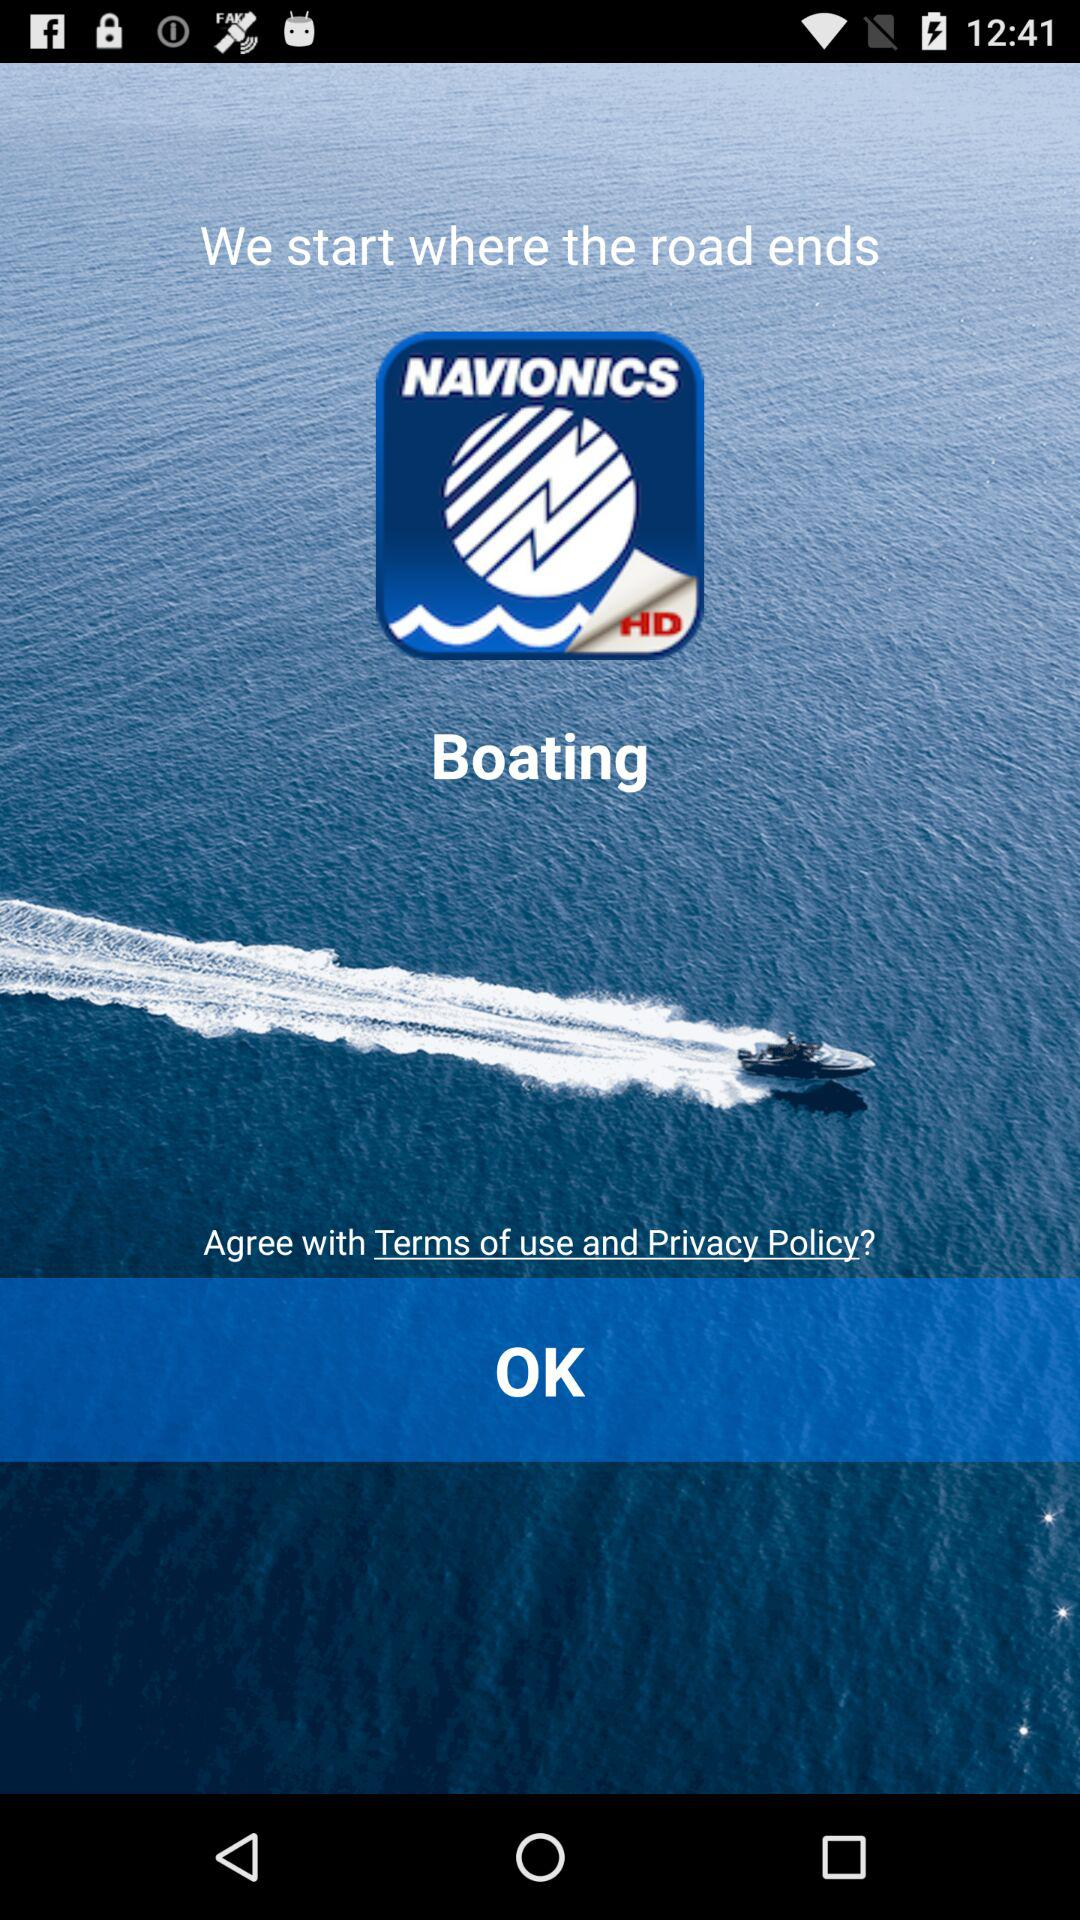What is the application name? The application name is "NAVIONICS". 